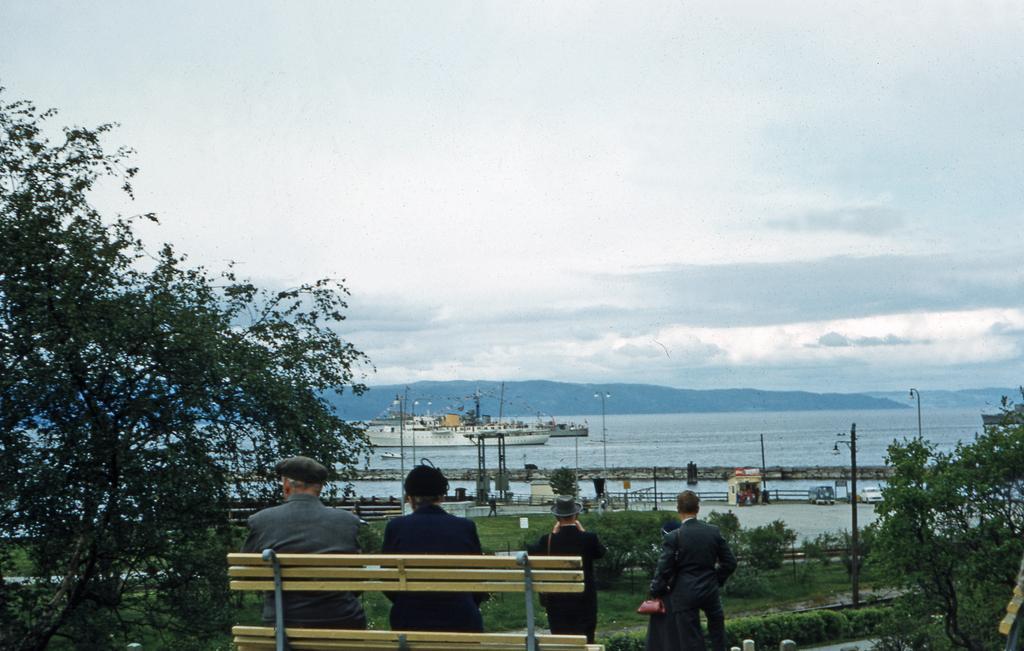Can you describe this image briefly? This picture shows a couple seated on the bench and we see few people standing and we see a ocean and ships and couple of trees and a blue cloudy Sky 